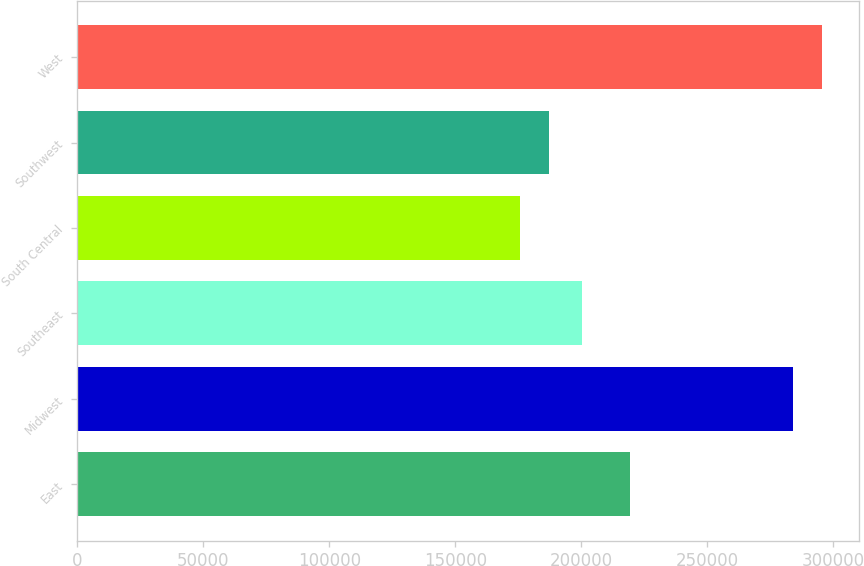Convert chart. <chart><loc_0><loc_0><loc_500><loc_500><bar_chart><fcel>East<fcel>Midwest<fcel>Southeast<fcel>South Central<fcel>Southwest<fcel>West<nl><fcel>219100<fcel>283800<fcel>200100<fcel>175800<fcel>187280<fcel>295280<nl></chart> 